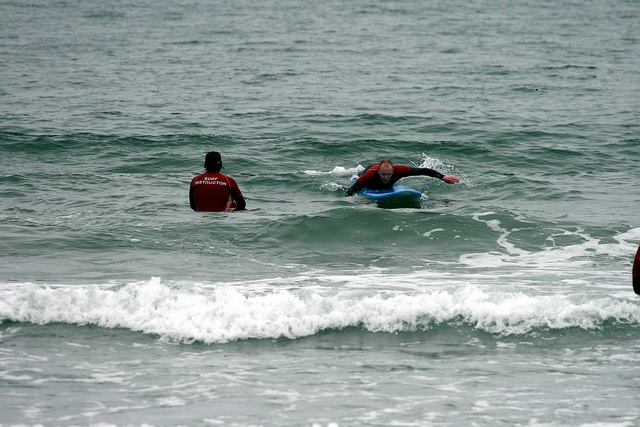Describe the objects in this image and their specific colors. I can see people in gray, black, maroon, and darkgray tones, people in gray, black, maroon, and brown tones, surfboard in gray, black, navy, and blue tones, and people in gray, black, and maroon tones in this image. 